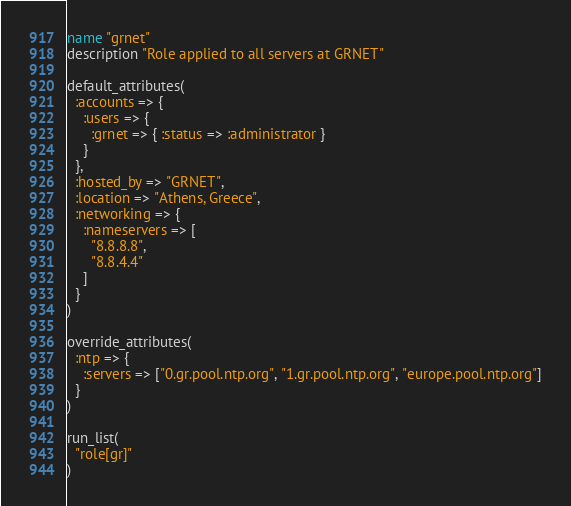<code> <loc_0><loc_0><loc_500><loc_500><_Ruby_>name "grnet"
description "Role applied to all servers at GRNET"

default_attributes(
  :accounts => {
    :users => {
      :grnet => { :status => :administrator }
    }
  },
  :hosted_by => "GRNET",
  :location => "Athens, Greece",
  :networking => {
    :nameservers => [
      "8.8.8.8",
      "8.8.4.4"
    ]
  }
)

override_attributes(
  :ntp => {
    :servers => ["0.gr.pool.ntp.org", "1.gr.pool.ntp.org", "europe.pool.ntp.org"]
  }
)

run_list(
  "role[gr]"
)
</code> 